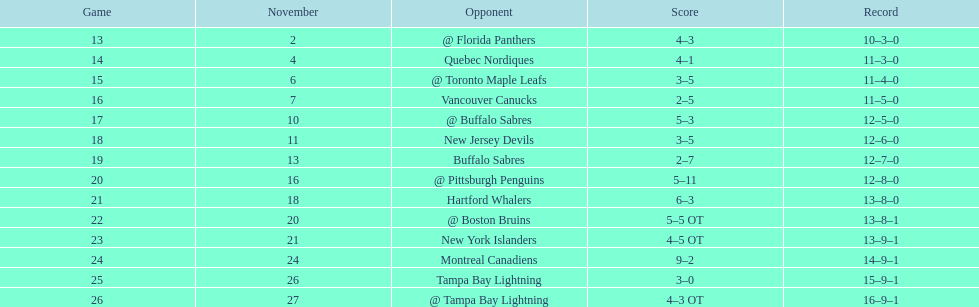Which teams scored 35 points or more in total? Hartford Whalers, @ Boston Bruins, New York Islanders, Montreal Canadiens, Tampa Bay Lightning, @ Tampa Bay Lightning. Of those teams, which team was the only one to score 3-0? Tampa Bay Lightning. 